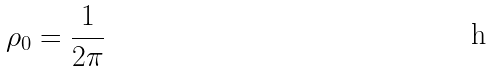Convert formula to latex. <formula><loc_0><loc_0><loc_500><loc_500>\rho _ { 0 } = \frac { 1 } { 2 \pi }</formula> 